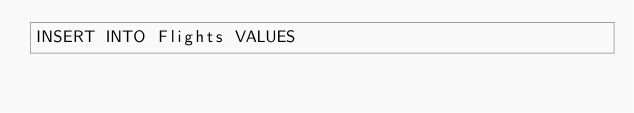<code> <loc_0><loc_0><loc_500><loc_500><_SQL_>INSERT INTO Flights VALUES</code> 